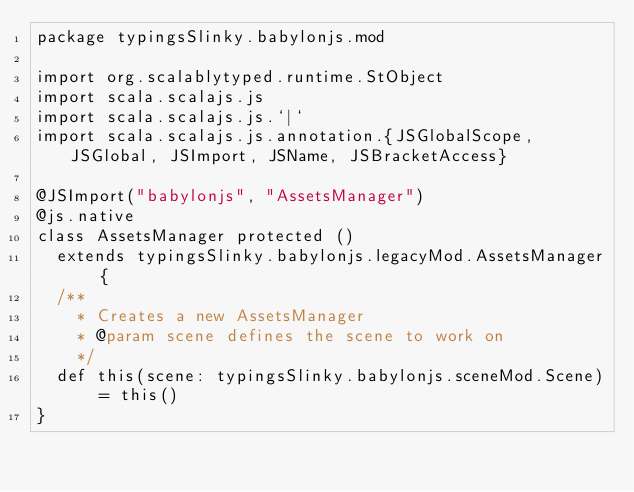Convert code to text. <code><loc_0><loc_0><loc_500><loc_500><_Scala_>package typingsSlinky.babylonjs.mod

import org.scalablytyped.runtime.StObject
import scala.scalajs.js
import scala.scalajs.js.`|`
import scala.scalajs.js.annotation.{JSGlobalScope, JSGlobal, JSImport, JSName, JSBracketAccess}

@JSImport("babylonjs", "AssetsManager")
@js.native
class AssetsManager protected ()
  extends typingsSlinky.babylonjs.legacyMod.AssetsManager {
  /**
    * Creates a new AssetsManager
    * @param scene defines the scene to work on
    */
  def this(scene: typingsSlinky.babylonjs.sceneMod.Scene) = this()
}
</code> 